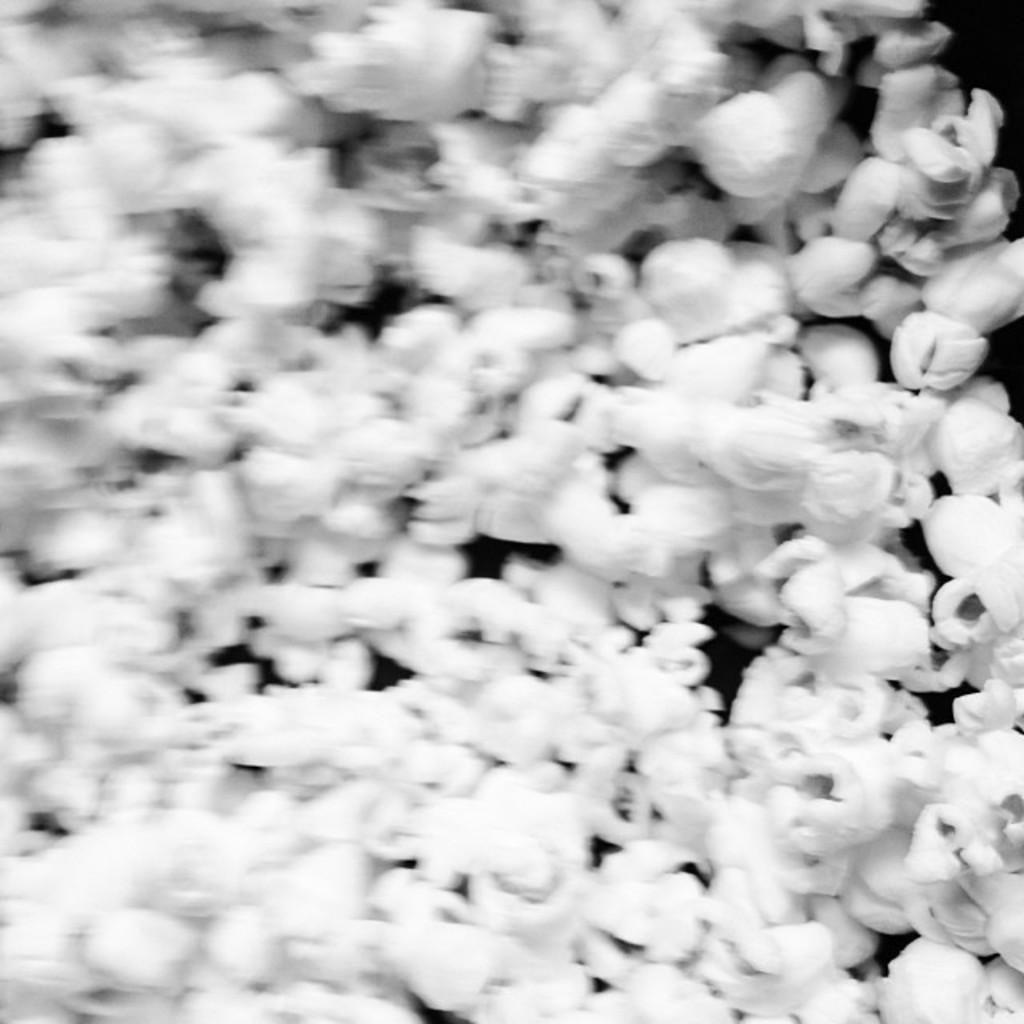What is the color scheme of the image? The image is black and white. What is depicted in the image? There is a picture of popcorn in the image. Is there a beggar asking for popcorn in the image? There is no beggar present in the image, and the image only features a picture of popcorn. Can you see any fangs on the popcorn in the image? The image is black and white and only features a picture of popcorn, so there are no visible fangs on the popcorn. 